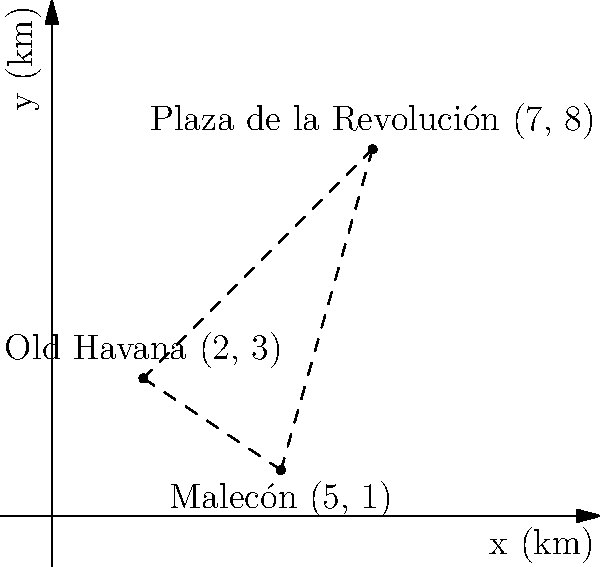As a welcoming host in Havana, you want to help tourists plan their visits efficiently. Using the coordinate system where each unit represents 1 km, three popular destinations are plotted: Old Havana at (2, 3), Plaza de la Revolución at (7, 8), and Malecón at (5, 1). What is the total distance, in kilometers, of a route that starts at Old Havana, goes to Plaza de la Revolución, then to Malecón, and finally back to Old Havana? Round your answer to the nearest tenth of a kilometer. Let's break this down step-by-step:

1) First, we need to calculate the distances between each pair of points using the distance formula: $d = \sqrt{(x_2-x_1)^2 + (y_2-y_1)^2}$

2) Distance from Old Havana to Plaza de la Revolución:
   $d_1 = \sqrt{(7-2)^2 + (8-3)^2} = \sqrt{5^2 + 5^2} = \sqrt{50} = 7.07$ km

3) Distance from Plaza de la Revolución to Malecón:
   $d_2 = \sqrt{(5-7)^2 + (1-8)^2} = \sqrt{(-2)^2 + (-7)^2} = \sqrt{4 + 49} = \sqrt{53} = 7.28$ km

4) Distance from Malecón back to Old Havana:
   $d_3 = \sqrt{(2-5)^2 + (3-1)^2} = \sqrt{(-3)^2 + 2^2} = \sqrt{9 + 4} = \sqrt{13} = 3.61$ km

5) Total distance = $d_1 + d_2 + d_3 = 7.07 + 7.28 + 3.61 = 17.96$ km

6) Rounding to the nearest tenth: 18.0 km
Answer: 18.0 km 